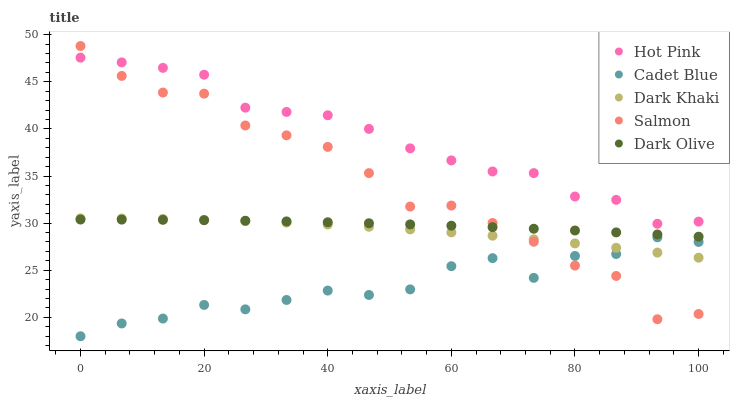Does Cadet Blue have the minimum area under the curve?
Answer yes or no. Yes. Does Hot Pink have the maximum area under the curve?
Answer yes or no. Yes. Does Dark Khaki have the minimum area under the curve?
Answer yes or no. No. Does Dark Khaki have the maximum area under the curve?
Answer yes or no. No. Is Dark Olive the smoothest?
Answer yes or no. Yes. Is Salmon the roughest?
Answer yes or no. Yes. Is Dark Khaki the smoothest?
Answer yes or no. No. Is Dark Khaki the roughest?
Answer yes or no. No. Does Cadet Blue have the lowest value?
Answer yes or no. Yes. Does Dark Khaki have the lowest value?
Answer yes or no. No. Does Salmon have the highest value?
Answer yes or no. Yes. Does Dark Khaki have the highest value?
Answer yes or no. No. Is Cadet Blue less than Dark Olive?
Answer yes or no. Yes. Is Hot Pink greater than Cadet Blue?
Answer yes or no. Yes. Does Dark Khaki intersect Salmon?
Answer yes or no. Yes. Is Dark Khaki less than Salmon?
Answer yes or no. No. Is Dark Khaki greater than Salmon?
Answer yes or no. No. Does Cadet Blue intersect Dark Olive?
Answer yes or no. No. 